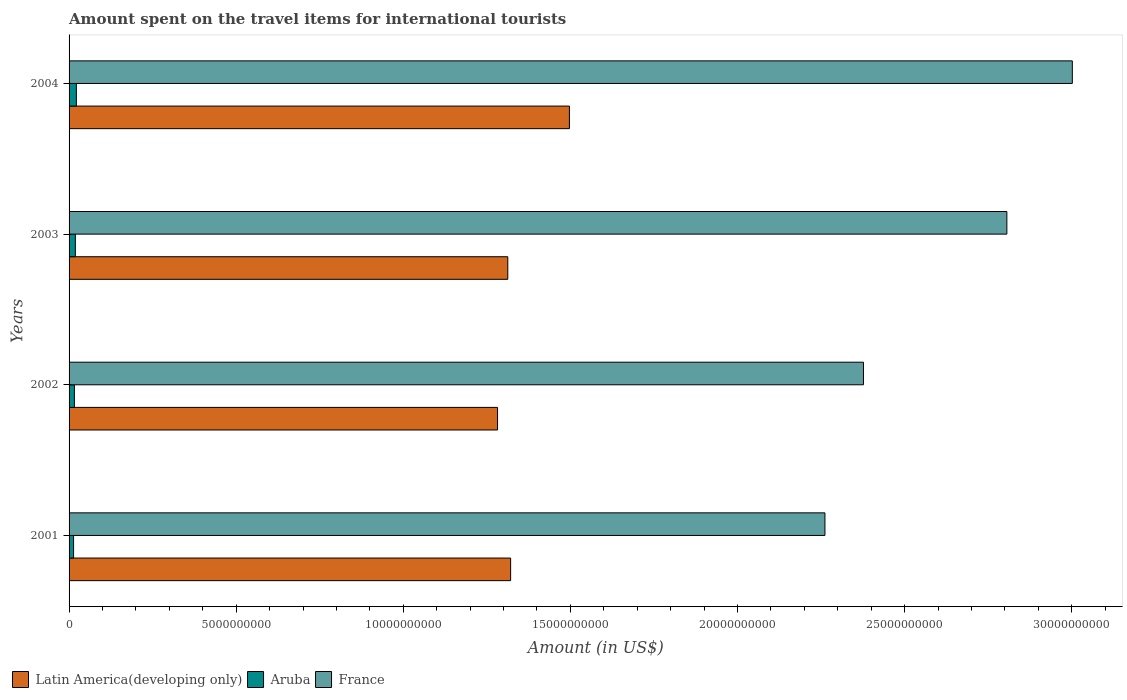How many different coloured bars are there?
Provide a short and direct response. 3. How many bars are there on the 1st tick from the top?
Your response must be concise. 3. How many bars are there on the 3rd tick from the bottom?
Keep it short and to the point. 3. What is the amount spent on the travel items for international tourists in Latin America(developing only) in 2003?
Your response must be concise. 1.31e+1. Across all years, what is the maximum amount spent on the travel items for international tourists in France?
Provide a succinct answer. 3.00e+1. Across all years, what is the minimum amount spent on the travel items for international tourists in France?
Provide a succinct answer. 2.26e+1. In which year was the amount spent on the travel items for international tourists in France minimum?
Your answer should be compact. 2001. What is the total amount spent on the travel items for international tourists in Latin America(developing only) in the graph?
Make the answer very short. 5.41e+1. What is the difference between the amount spent on the travel items for international tourists in Aruba in 2002 and that in 2004?
Provide a succinct answer. -5.90e+07. What is the difference between the amount spent on the travel items for international tourists in Latin America(developing only) in 2001 and the amount spent on the travel items for international tourists in France in 2003?
Your answer should be very brief. -1.48e+1. What is the average amount spent on the travel items for international tourists in France per year?
Your answer should be very brief. 2.61e+1. In the year 2004, what is the difference between the amount spent on the travel items for international tourists in France and amount spent on the travel items for international tourists in Aruba?
Provide a succinct answer. 2.98e+1. What is the ratio of the amount spent on the travel items for international tourists in France in 2002 to that in 2003?
Your answer should be very brief. 0.85. Is the difference between the amount spent on the travel items for international tourists in France in 2001 and 2002 greater than the difference between the amount spent on the travel items for international tourists in Aruba in 2001 and 2002?
Your answer should be very brief. No. What is the difference between the highest and the second highest amount spent on the travel items for international tourists in Aruba?
Provide a short and direct response. 3.00e+07. What is the difference between the highest and the lowest amount spent on the travel items for international tourists in Latin America(developing only)?
Keep it short and to the point. 2.15e+09. In how many years, is the amount spent on the travel items for international tourists in Aruba greater than the average amount spent on the travel items for international tourists in Aruba taken over all years?
Offer a terse response. 2. Is the sum of the amount spent on the travel items for international tourists in France in 2001 and 2002 greater than the maximum amount spent on the travel items for international tourists in Aruba across all years?
Provide a succinct answer. Yes. What does the 2nd bar from the top in 2003 represents?
Offer a very short reply. Aruba. What does the 3rd bar from the bottom in 2003 represents?
Keep it short and to the point. France. How many bars are there?
Offer a terse response. 12. How many years are there in the graph?
Ensure brevity in your answer.  4. What is the difference between two consecutive major ticks on the X-axis?
Ensure brevity in your answer.  5.00e+09. Where does the legend appear in the graph?
Your answer should be compact. Bottom left. What is the title of the graph?
Provide a short and direct response. Amount spent on the travel items for international tourists. Does "Palau" appear as one of the legend labels in the graph?
Ensure brevity in your answer.  No. What is the label or title of the X-axis?
Give a very brief answer. Amount (in US$). What is the Amount (in US$) of Latin America(developing only) in 2001?
Provide a succinct answer. 1.32e+1. What is the Amount (in US$) of Aruba in 2001?
Your response must be concise. 1.35e+08. What is the Amount (in US$) of France in 2001?
Offer a very short reply. 2.26e+1. What is the Amount (in US$) of Latin America(developing only) in 2002?
Your response must be concise. 1.28e+1. What is the Amount (in US$) in Aruba in 2002?
Your answer should be compact. 1.59e+08. What is the Amount (in US$) in France in 2002?
Provide a short and direct response. 2.38e+1. What is the Amount (in US$) of Latin America(developing only) in 2003?
Provide a short and direct response. 1.31e+1. What is the Amount (in US$) in Aruba in 2003?
Ensure brevity in your answer.  1.88e+08. What is the Amount (in US$) in France in 2003?
Offer a very short reply. 2.81e+1. What is the Amount (in US$) in Latin America(developing only) in 2004?
Provide a short and direct response. 1.50e+1. What is the Amount (in US$) in Aruba in 2004?
Ensure brevity in your answer.  2.18e+08. What is the Amount (in US$) in France in 2004?
Your answer should be very brief. 3.00e+1. Across all years, what is the maximum Amount (in US$) in Latin America(developing only)?
Provide a short and direct response. 1.50e+1. Across all years, what is the maximum Amount (in US$) of Aruba?
Your answer should be compact. 2.18e+08. Across all years, what is the maximum Amount (in US$) of France?
Your answer should be compact. 3.00e+1. Across all years, what is the minimum Amount (in US$) of Latin America(developing only)?
Your answer should be very brief. 1.28e+1. Across all years, what is the minimum Amount (in US$) in Aruba?
Your answer should be very brief. 1.35e+08. Across all years, what is the minimum Amount (in US$) of France?
Give a very brief answer. 2.26e+1. What is the total Amount (in US$) of Latin America(developing only) in the graph?
Your answer should be very brief. 5.41e+1. What is the total Amount (in US$) of Aruba in the graph?
Your answer should be very brief. 7.00e+08. What is the total Amount (in US$) of France in the graph?
Make the answer very short. 1.04e+11. What is the difference between the Amount (in US$) of Latin America(developing only) in 2001 and that in 2002?
Keep it short and to the point. 3.91e+08. What is the difference between the Amount (in US$) of Aruba in 2001 and that in 2002?
Your answer should be very brief. -2.40e+07. What is the difference between the Amount (in US$) in France in 2001 and that in 2002?
Provide a succinct answer. -1.15e+09. What is the difference between the Amount (in US$) of Latin America(developing only) in 2001 and that in 2003?
Make the answer very short. 8.46e+07. What is the difference between the Amount (in US$) of Aruba in 2001 and that in 2003?
Provide a short and direct response. -5.30e+07. What is the difference between the Amount (in US$) of France in 2001 and that in 2003?
Your answer should be compact. -5.44e+09. What is the difference between the Amount (in US$) in Latin America(developing only) in 2001 and that in 2004?
Offer a very short reply. -1.76e+09. What is the difference between the Amount (in US$) in Aruba in 2001 and that in 2004?
Your answer should be very brief. -8.30e+07. What is the difference between the Amount (in US$) of France in 2001 and that in 2004?
Your response must be concise. -7.40e+09. What is the difference between the Amount (in US$) of Latin America(developing only) in 2002 and that in 2003?
Make the answer very short. -3.07e+08. What is the difference between the Amount (in US$) in Aruba in 2002 and that in 2003?
Ensure brevity in your answer.  -2.90e+07. What is the difference between the Amount (in US$) in France in 2002 and that in 2003?
Provide a succinct answer. -4.29e+09. What is the difference between the Amount (in US$) of Latin America(developing only) in 2002 and that in 2004?
Give a very brief answer. -2.15e+09. What is the difference between the Amount (in US$) of Aruba in 2002 and that in 2004?
Ensure brevity in your answer.  -5.90e+07. What is the difference between the Amount (in US$) in France in 2002 and that in 2004?
Make the answer very short. -6.25e+09. What is the difference between the Amount (in US$) in Latin America(developing only) in 2003 and that in 2004?
Make the answer very short. -1.84e+09. What is the difference between the Amount (in US$) in Aruba in 2003 and that in 2004?
Provide a short and direct response. -3.00e+07. What is the difference between the Amount (in US$) in France in 2003 and that in 2004?
Your response must be concise. -1.96e+09. What is the difference between the Amount (in US$) in Latin America(developing only) in 2001 and the Amount (in US$) in Aruba in 2002?
Make the answer very short. 1.31e+1. What is the difference between the Amount (in US$) in Latin America(developing only) in 2001 and the Amount (in US$) in France in 2002?
Your response must be concise. -1.06e+1. What is the difference between the Amount (in US$) of Aruba in 2001 and the Amount (in US$) of France in 2002?
Provide a short and direct response. -2.36e+1. What is the difference between the Amount (in US$) in Latin America(developing only) in 2001 and the Amount (in US$) in Aruba in 2003?
Ensure brevity in your answer.  1.30e+1. What is the difference between the Amount (in US$) in Latin America(developing only) in 2001 and the Amount (in US$) in France in 2003?
Your answer should be compact. -1.48e+1. What is the difference between the Amount (in US$) in Aruba in 2001 and the Amount (in US$) in France in 2003?
Ensure brevity in your answer.  -2.79e+1. What is the difference between the Amount (in US$) of Latin America(developing only) in 2001 and the Amount (in US$) of Aruba in 2004?
Offer a very short reply. 1.30e+1. What is the difference between the Amount (in US$) in Latin America(developing only) in 2001 and the Amount (in US$) in France in 2004?
Make the answer very short. -1.68e+1. What is the difference between the Amount (in US$) of Aruba in 2001 and the Amount (in US$) of France in 2004?
Offer a very short reply. -2.99e+1. What is the difference between the Amount (in US$) of Latin America(developing only) in 2002 and the Amount (in US$) of Aruba in 2003?
Your response must be concise. 1.26e+1. What is the difference between the Amount (in US$) in Latin America(developing only) in 2002 and the Amount (in US$) in France in 2003?
Offer a terse response. -1.52e+1. What is the difference between the Amount (in US$) in Aruba in 2002 and the Amount (in US$) in France in 2003?
Your response must be concise. -2.79e+1. What is the difference between the Amount (in US$) of Latin America(developing only) in 2002 and the Amount (in US$) of Aruba in 2004?
Keep it short and to the point. 1.26e+1. What is the difference between the Amount (in US$) in Latin America(developing only) in 2002 and the Amount (in US$) in France in 2004?
Your answer should be very brief. -1.72e+1. What is the difference between the Amount (in US$) of Aruba in 2002 and the Amount (in US$) of France in 2004?
Your response must be concise. -2.99e+1. What is the difference between the Amount (in US$) of Latin America(developing only) in 2003 and the Amount (in US$) of Aruba in 2004?
Provide a succinct answer. 1.29e+1. What is the difference between the Amount (in US$) in Latin America(developing only) in 2003 and the Amount (in US$) in France in 2004?
Make the answer very short. -1.69e+1. What is the difference between the Amount (in US$) of Aruba in 2003 and the Amount (in US$) of France in 2004?
Provide a succinct answer. -2.98e+1. What is the average Amount (in US$) in Latin America(developing only) per year?
Offer a terse response. 1.35e+1. What is the average Amount (in US$) in Aruba per year?
Your answer should be very brief. 1.75e+08. What is the average Amount (in US$) of France per year?
Give a very brief answer. 2.61e+1. In the year 2001, what is the difference between the Amount (in US$) of Latin America(developing only) and Amount (in US$) of Aruba?
Provide a short and direct response. 1.31e+1. In the year 2001, what is the difference between the Amount (in US$) of Latin America(developing only) and Amount (in US$) of France?
Give a very brief answer. -9.40e+09. In the year 2001, what is the difference between the Amount (in US$) of Aruba and Amount (in US$) of France?
Make the answer very short. -2.25e+1. In the year 2002, what is the difference between the Amount (in US$) of Latin America(developing only) and Amount (in US$) of Aruba?
Provide a short and direct response. 1.27e+1. In the year 2002, what is the difference between the Amount (in US$) of Latin America(developing only) and Amount (in US$) of France?
Offer a very short reply. -1.09e+1. In the year 2002, what is the difference between the Amount (in US$) of Aruba and Amount (in US$) of France?
Your answer should be very brief. -2.36e+1. In the year 2003, what is the difference between the Amount (in US$) in Latin America(developing only) and Amount (in US$) in Aruba?
Ensure brevity in your answer.  1.29e+1. In the year 2003, what is the difference between the Amount (in US$) in Latin America(developing only) and Amount (in US$) in France?
Offer a terse response. -1.49e+1. In the year 2003, what is the difference between the Amount (in US$) in Aruba and Amount (in US$) in France?
Ensure brevity in your answer.  -2.79e+1. In the year 2004, what is the difference between the Amount (in US$) in Latin America(developing only) and Amount (in US$) in Aruba?
Give a very brief answer. 1.48e+1. In the year 2004, what is the difference between the Amount (in US$) of Latin America(developing only) and Amount (in US$) of France?
Provide a short and direct response. -1.50e+1. In the year 2004, what is the difference between the Amount (in US$) in Aruba and Amount (in US$) in France?
Make the answer very short. -2.98e+1. What is the ratio of the Amount (in US$) of Latin America(developing only) in 2001 to that in 2002?
Make the answer very short. 1.03. What is the ratio of the Amount (in US$) in Aruba in 2001 to that in 2002?
Your answer should be very brief. 0.85. What is the ratio of the Amount (in US$) in France in 2001 to that in 2002?
Offer a very short reply. 0.95. What is the ratio of the Amount (in US$) of Latin America(developing only) in 2001 to that in 2003?
Your response must be concise. 1.01. What is the ratio of the Amount (in US$) of Aruba in 2001 to that in 2003?
Make the answer very short. 0.72. What is the ratio of the Amount (in US$) in France in 2001 to that in 2003?
Provide a succinct answer. 0.81. What is the ratio of the Amount (in US$) in Latin America(developing only) in 2001 to that in 2004?
Offer a very short reply. 0.88. What is the ratio of the Amount (in US$) in Aruba in 2001 to that in 2004?
Ensure brevity in your answer.  0.62. What is the ratio of the Amount (in US$) in France in 2001 to that in 2004?
Your answer should be compact. 0.75. What is the ratio of the Amount (in US$) in Latin America(developing only) in 2002 to that in 2003?
Offer a very short reply. 0.98. What is the ratio of the Amount (in US$) in Aruba in 2002 to that in 2003?
Keep it short and to the point. 0.85. What is the ratio of the Amount (in US$) of France in 2002 to that in 2003?
Provide a succinct answer. 0.85. What is the ratio of the Amount (in US$) of Latin America(developing only) in 2002 to that in 2004?
Make the answer very short. 0.86. What is the ratio of the Amount (in US$) in Aruba in 2002 to that in 2004?
Make the answer very short. 0.73. What is the ratio of the Amount (in US$) in France in 2002 to that in 2004?
Provide a succinct answer. 0.79. What is the ratio of the Amount (in US$) in Latin America(developing only) in 2003 to that in 2004?
Give a very brief answer. 0.88. What is the ratio of the Amount (in US$) in Aruba in 2003 to that in 2004?
Keep it short and to the point. 0.86. What is the ratio of the Amount (in US$) of France in 2003 to that in 2004?
Offer a very short reply. 0.93. What is the difference between the highest and the second highest Amount (in US$) of Latin America(developing only)?
Give a very brief answer. 1.76e+09. What is the difference between the highest and the second highest Amount (in US$) in Aruba?
Your response must be concise. 3.00e+07. What is the difference between the highest and the second highest Amount (in US$) in France?
Provide a short and direct response. 1.96e+09. What is the difference between the highest and the lowest Amount (in US$) in Latin America(developing only)?
Provide a short and direct response. 2.15e+09. What is the difference between the highest and the lowest Amount (in US$) in Aruba?
Your answer should be compact. 8.30e+07. What is the difference between the highest and the lowest Amount (in US$) of France?
Provide a short and direct response. 7.40e+09. 